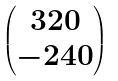Convert formula to latex. <formula><loc_0><loc_0><loc_500><loc_500>\begin{pmatrix} 3 2 0 \\ - 2 4 0 \end{pmatrix}</formula> 